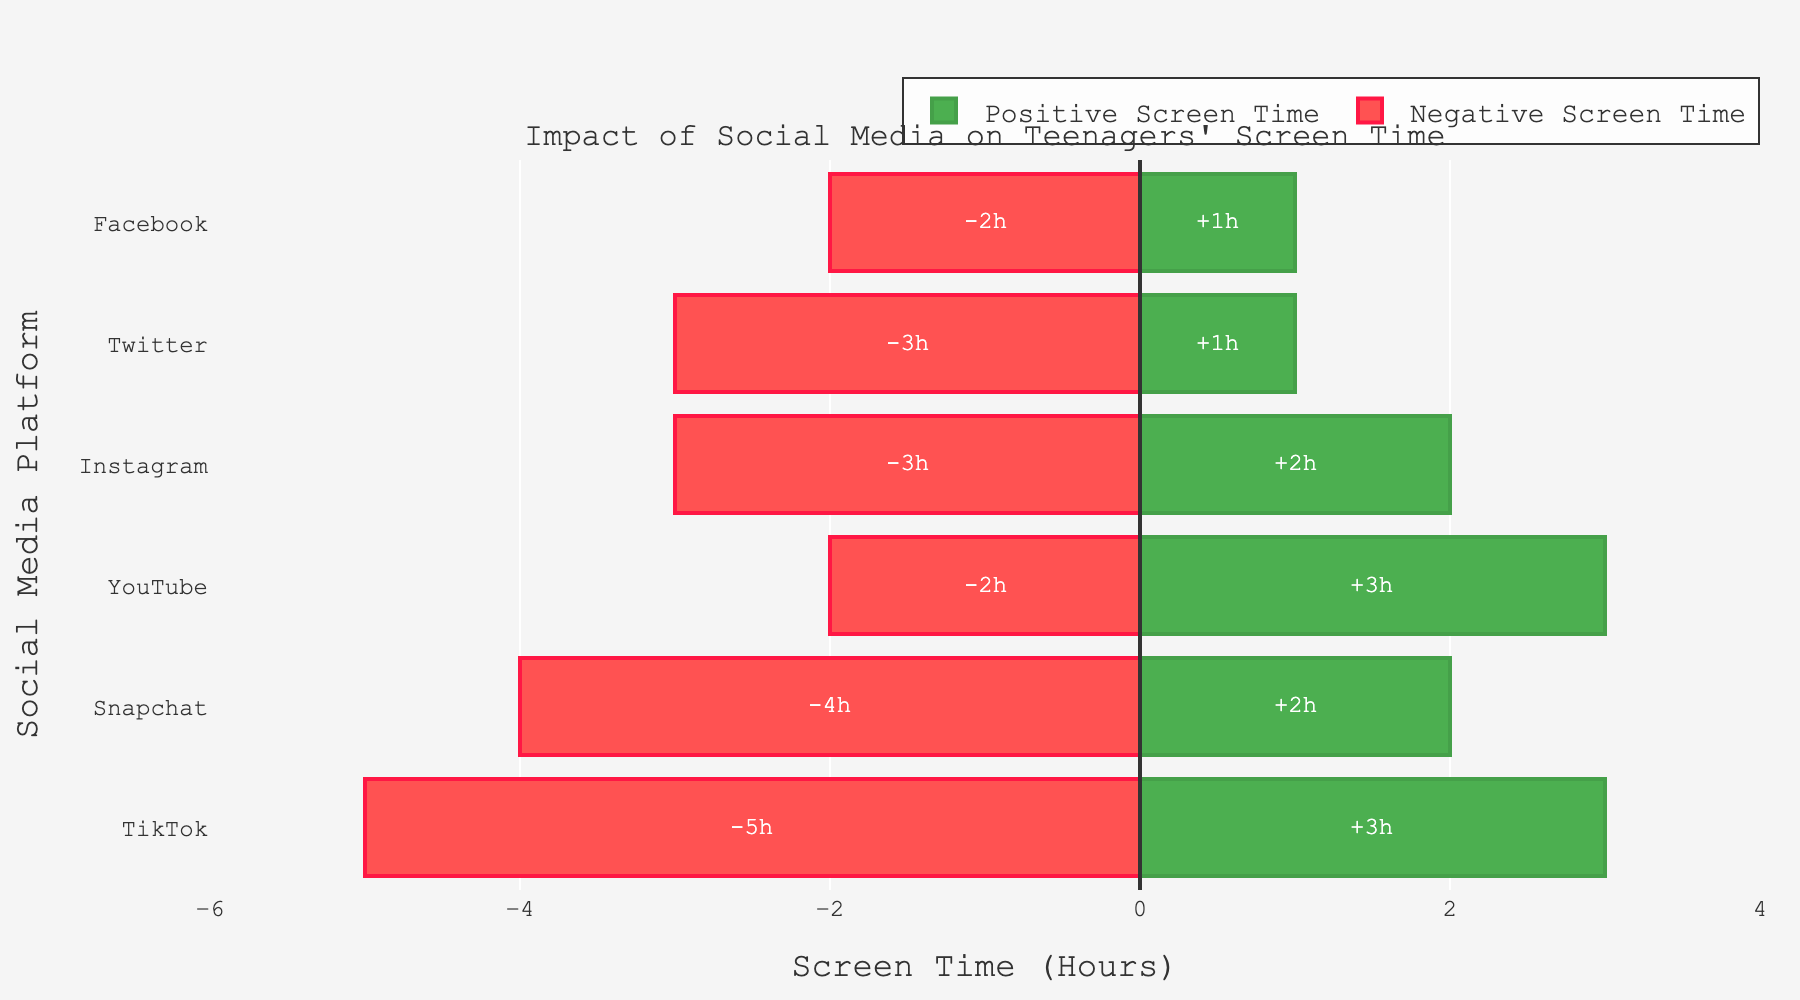Which social media platform has the highest positive screen time? By observing the green bars representing positive screen time, YouTube has the longest green bar.
Answer: YouTube Which social media platform has the highest negative screen time? By observing the red bars representing negative screen time, TikTok has the longest red bar.
Answer: TikTok What is the total screen time for Instagram? Instagram has 2 hours of positive screen time and 3 hours of negative screen time. Adding them together: 2 + 3 = 5 hours.
Answer: 5 hours Which platform has more negative screen time: Snapchat or Facebook? Compare the lengths of the red bars for Snapchat and Facebook. Snapchat's red bar is longer, representing 4 hours compared to Facebook's 2 hours.
Answer: Snapchat Which social media platform minimal impact (combined positive and negative screen time)? Compare the combined lengths of both the green and red bars for each platform. Facebook has the shortest combined length.
Answer: Facebook What is the average positive screen time across all platforms? Sum the positive screen times (3+2+2+3+1+1=12) and divide by the number of platforms (6). 12 / 6 = 2 hours.
Answer: 2 hours How many platforms have more negative screen time than positive screen time? By observing the lengths of the green and red bars, Instagram, Snapchat, TikTok, and Twitter have longer red bars (negative) than green bars (positive).
Answer: 4 platforms What is the difference in total screen time between YouTube and Twitter? For YouTube: 3 + 2 = 5 hours. For Twitter: 1 + 3 = 4 hours. Difference: 5 - 4 = 1 hour.
Answer: 1 hour Which platform has the most balanced impact in terms of positive and negative screen time? The most balanced impact will have similar lengths of green and red bars. YouTube has 3 hours of positive and 2 hours of negative screen time, which is the closest balance.
Answer: YouTube What is the combined screen time for Snapchat and TikTok? For Snapchat: 2 (positive) + 4 (negative) = 6 hours. For TikTok: 3 (positive) + 5 (negative) = 8 hours. Combined: 6 + 8 = 14 hours.
Answer: 14 hours 